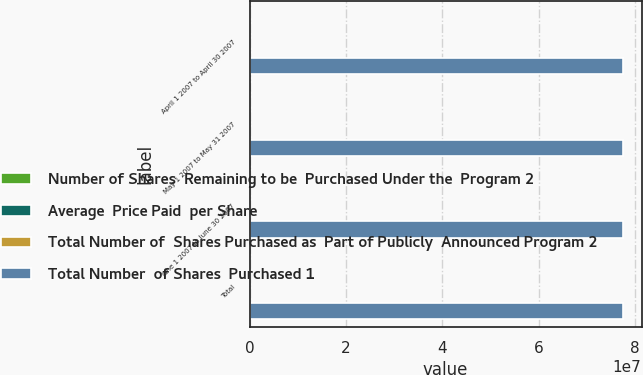Convert chart to OTSL. <chart><loc_0><loc_0><loc_500><loc_500><stacked_bar_chart><ecel><fcel>April 1 2007 to April 30 2007<fcel>May 1 2007 to May 31 2007<fcel>June 1 2007 to June 30 2007<fcel>Total<nl><fcel>Number of Shares  Remaining to be  Purchased Under the  Program 2<fcel>4<fcel>33372<fcel>9260<fcel>42636<nl><fcel>Average  Price Paid  per Share<fcel>37.25<fcel>36.47<fcel>34.47<fcel>36.04<nl><fcel>Total Number of  Shares Purchased as  Part of Publicly  Announced Program 2<fcel>4<fcel>235<fcel>184<fcel>423<nl><fcel>Total Number  of Shares  Purchased 1<fcel>7.75021e+07<fcel>7.75018e+07<fcel>7.75017e+07<fcel>7.75017e+07<nl></chart> 